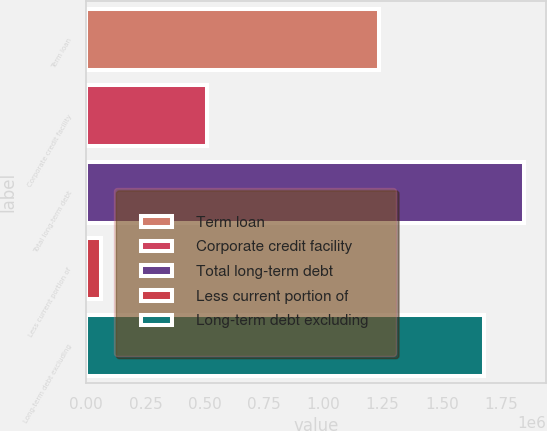<chart> <loc_0><loc_0><loc_500><loc_500><bar_chart><fcel>Term loan<fcel>Corporate credit facility<fcel>Total long-term debt<fcel>Less current portion of<fcel>Long-term debt excluding<nl><fcel>1.23438e+06<fcel>508125<fcel>1.848e+06<fcel>62500<fcel>1.68e+06<nl></chart> 